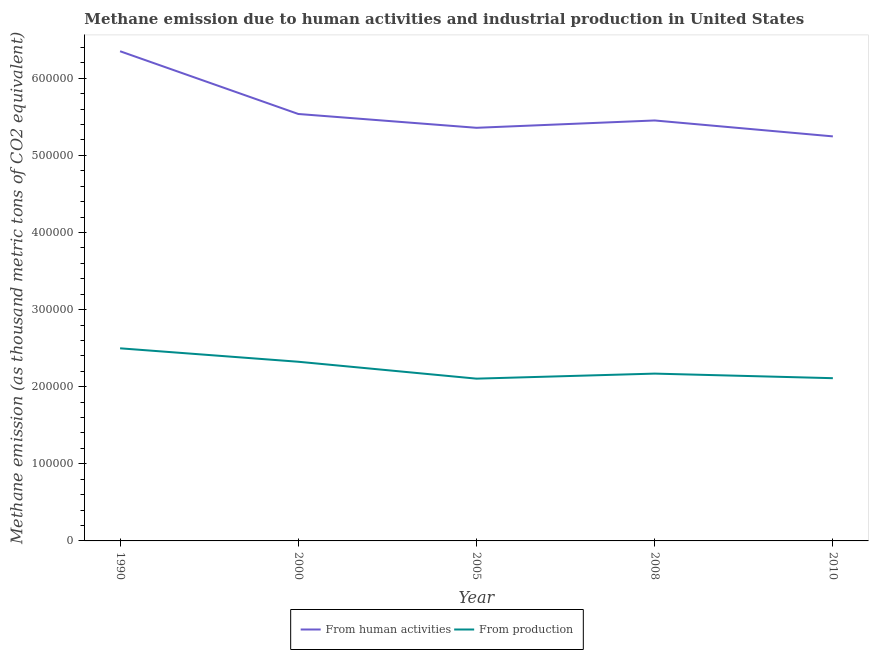How many different coloured lines are there?
Keep it short and to the point. 2. Does the line corresponding to amount of emissions generated from industries intersect with the line corresponding to amount of emissions from human activities?
Make the answer very short. No. What is the amount of emissions from human activities in 2010?
Offer a terse response. 5.25e+05. Across all years, what is the maximum amount of emissions generated from industries?
Your response must be concise. 2.50e+05. Across all years, what is the minimum amount of emissions generated from industries?
Provide a short and direct response. 2.10e+05. In which year was the amount of emissions generated from industries minimum?
Offer a very short reply. 2005. What is the total amount of emissions from human activities in the graph?
Your answer should be compact. 2.79e+06. What is the difference between the amount of emissions generated from industries in 2008 and that in 2010?
Your answer should be very brief. 5939.8. What is the difference between the amount of emissions from human activities in 2010 and the amount of emissions generated from industries in 1990?
Give a very brief answer. 2.75e+05. What is the average amount of emissions generated from industries per year?
Give a very brief answer. 2.24e+05. In the year 2008, what is the difference between the amount of emissions generated from industries and amount of emissions from human activities?
Your answer should be compact. -3.28e+05. What is the ratio of the amount of emissions generated from industries in 1990 to that in 2010?
Provide a short and direct response. 1.18. Is the amount of emissions generated from industries in 2000 less than that in 2010?
Your answer should be very brief. No. Is the difference between the amount of emissions from human activities in 2005 and 2010 greater than the difference between the amount of emissions generated from industries in 2005 and 2010?
Your answer should be very brief. Yes. What is the difference between the highest and the second highest amount of emissions from human activities?
Your answer should be very brief. 8.14e+04. What is the difference between the highest and the lowest amount of emissions generated from industries?
Your answer should be compact. 3.93e+04. In how many years, is the amount of emissions generated from industries greater than the average amount of emissions generated from industries taken over all years?
Keep it short and to the point. 2. Does the amount of emissions generated from industries monotonically increase over the years?
Offer a very short reply. No. Is the amount of emissions generated from industries strictly less than the amount of emissions from human activities over the years?
Make the answer very short. Yes. How many lines are there?
Give a very brief answer. 2. How many years are there in the graph?
Ensure brevity in your answer.  5. What is the difference between two consecutive major ticks on the Y-axis?
Provide a succinct answer. 1.00e+05. Does the graph contain any zero values?
Ensure brevity in your answer.  No. How many legend labels are there?
Your answer should be compact. 2. How are the legend labels stacked?
Ensure brevity in your answer.  Horizontal. What is the title of the graph?
Your answer should be very brief. Methane emission due to human activities and industrial production in United States. What is the label or title of the Y-axis?
Make the answer very short. Methane emission (as thousand metric tons of CO2 equivalent). What is the Methane emission (as thousand metric tons of CO2 equivalent) of From human activities in 1990?
Provide a succinct answer. 6.35e+05. What is the Methane emission (as thousand metric tons of CO2 equivalent) in From production in 1990?
Your answer should be very brief. 2.50e+05. What is the Methane emission (as thousand metric tons of CO2 equivalent) in From human activities in 2000?
Ensure brevity in your answer.  5.54e+05. What is the Methane emission (as thousand metric tons of CO2 equivalent) of From production in 2000?
Offer a terse response. 2.32e+05. What is the Methane emission (as thousand metric tons of CO2 equivalent) in From human activities in 2005?
Offer a very short reply. 5.36e+05. What is the Methane emission (as thousand metric tons of CO2 equivalent) of From production in 2005?
Ensure brevity in your answer.  2.10e+05. What is the Methane emission (as thousand metric tons of CO2 equivalent) in From human activities in 2008?
Provide a short and direct response. 5.45e+05. What is the Methane emission (as thousand metric tons of CO2 equivalent) in From production in 2008?
Ensure brevity in your answer.  2.17e+05. What is the Methane emission (as thousand metric tons of CO2 equivalent) of From human activities in 2010?
Provide a succinct answer. 5.25e+05. What is the Methane emission (as thousand metric tons of CO2 equivalent) in From production in 2010?
Offer a very short reply. 2.11e+05. Across all years, what is the maximum Methane emission (as thousand metric tons of CO2 equivalent) in From human activities?
Offer a very short reply. 6.35e+05. Across all years, what is the maximum Methane emission (as thousand metric tons of CO2 equivalent) in From production?
Provide a succinct answer. 2.50e+05. Across all years, what is the minimum Methane emission (as thousand metric tons of CO2 equivalent) in From human activities?
Your answer should be compact. 5.25e+05. Across all years, what is the minimum Methane emission (as thousand metric tons of CO2 equivalent) of From production?
Offer a terse response. 2.10e+05. What is the total Methane emission (as thousand metric tons of CO2 equivalent) in From human activities in the graph?
Your answer should be compact. 2.79e+06. What is the total Methane emission (as thousand metric tons of CO2 equivalent) in From production in the graph?
Make the answer very short. 1.12e+06. What is the difference between the Methane emission (as thousand metric tons of CO2 equivalent) of From human activities in 1990 and that in 2000?
Offer a terse response. 8.14e+04. What is the difference between the Methane emission (as thousand metric tons of CO2 equivalent) of From production in 1990 and that in 2000?
Your response must be concise. 1.74e+04. What is the difference between the Methane emission (as thousand metric tons of CO2 equivalent) in From human activities in 1990 and that in 2005?
Make the answer very short. 9.93e+04. What is the difference between the Methane emission (as thousand metric tons of CO2 equivalent) in From production in 1990 and that in 2005?
Your response must be concise. 3.93e+04. What is the difference between the Methane emission (as thousand metric tons of CO2 equivalent) in From human activities in 1990 and that in 2008?
Your answer should be very brief. 8.98e+04. What is the difference between the Methane emission (as thousand metric tons of CO2 equivalent) in From production in 1990 and that in 2008?
Provide a short and direct response. 3.28e+04. What is the difference between the Methane emission (as thousand metric tons of CO2 equivalent) of From human activities in 1990 and that in 2010?
Give a very brief answer. 1.10e+05. What is the difference between the Methane emission (as thousand metric tons of CO2 equivalent) in From production in 1990 and that in 2010?
Provide a succinct answer. 3.87e+04. What is the difference between the Methane emission (as thousand metric tons of CO2 equivalent) in From human activities in 2000 and that in 2005?
Your answer should be very brief. 1.79e+04. What is the difference between the Methane emission (as thousand metric tons of CO2 equivalent) of From production in 2000 and that in 2005?
Your response must be concise. 2.19e+04. What is the difference between the Methane emission (as thousand metric tons of CO2 equivalent) in From human activities in 2000 and that in 2008?
Your response must be concise. 8414.7. What is the difference between the Methane emission (as thousand metric tons of CO2 equivalent) in From production in 2000 and that in 2008?
Give a very brief answer. 1.54e+04. What is the difference between the Methane emission (as thousand metric tons of CO2 equivalent) in From human activities in 2000 and that in 2010?
Offer a very short reply. 2.91e+04. What is the difference between the Methane emission (as thousand metric tons of CO2 equivalent) of From production in 2000 and that in 2010?
Offer a terse response. 2.13e+04. What is the difference between the Methane emission (as thousand metric tons of CO2 equivalent) in From human activities in 2005 and that in 2008?
Keep it short and to the point. -9510.3. What is the difference between the Methane emission (as thousand metric tons of CO2 equivalent) of From production in 2005 and that in 2008?
Give a very brief answer. -6538.2. What is the difference between the Methane emission (as thousand metric tons of CO2 equivalent) in From human activities in 2005 and that in 2010?
Make the answer very short. 1.11e+04. What is the difference between the Methane emission (as thousand metric tons of CO2 equivalent) in From production in 2005 and that in 2010?
Your answer should be very brief. -598.4. What is the difference between the Methane emission (as thousand metric tons of CO2 equivalent) in From human activities in 2008 and that in 2010?
Provide a succinct answer. 2.06e+04. What is the difference between the Methane emission (as thousand metric tons of CO2 equivalent) in From production in 2008 and that in 2010?
Ensure brevity in your answer.  5939.8. What is the difference between the Methane emission (as thousand metric tons of CO2 equivalent) in From human activities in 1990 and the Methane emission (as thousand metric tons of CO2 equivalent) in From production in 2000?
Offer a very short reply. 4.03e+05. What is the difference between the Methane emission (as thousand metric tons of CO2 equivalent) of From human activities in 1990 and the Methane emission (as thousand metric tons of CO2 equivalent) of From production in 2005?
Offer a very short reply. 4.25e+05. What is the difference between the Methane emission (as thousand metric tons of CO2 equivalent) of From human activities in 1990 and the Methane emission (as thousand metric tons of CO2 equivalent) of From production in 2008?
Offer a very short reply. 4.18e+05. What is the difference between the Methane emission (as thousand metric tons of CO2 equivalent) of From human activities in 1990 and the Methane emission (as thousand metric tons of CO2 equivalent) of From production in 2010?
Your answer should be compact. 4.24e+05. What is the difference between the Methane emission (as thousand metric tons of CO2 equivalent) of From human activities in 2000 and the Methane emission (as thousand metric tons of CO2 equivalent) of From production in 2005?
Offer a very short reply. 3.43e+05. What is the difference between the Methane emission (as thousand metric tons of CO2 equivalent) of From human activities in 2000 and the Methane emission (as thousand metric tons of CO2 equivalent) of From production in 2008?
Offer a very short reply. 3.37e+05. What is the difference between the Methane emission (as thousand metric tons of CO2 equivalent) of From human activities in 2000 and the Methane emission (as thousand metric tons of CO2 equivalent) of From production in 2010?
Your response must be concise. 3.43e+05. What is the difference between the Methane emission (as thousand metric tons of CO2 equivalent) of From human activities in 2005 and the Methane emission (as thousand metric tons of CO2 equivalent) of From production in 2008?
Your answer should be compact. 3.19e+05. What is the difference between the Methane emission (as thousand metric tons of CO2 equivalent) of From human activities in 2005 and the Methane emission (as thousand metric tons of CO2 equivalent) of From production in 2010?
Your answer should be compact. 3.25e+05. What is the difference between the Methane emission (as thousand metric tons of CO2 equivalent) in From human activities in 2008 and the Methane emission (as thousand metric tons of CO2 equivalent) in From production in 2010?
Provide a succinct answer. 3.34e+05. What is the average Methane emission (as thousand metric tons of CO2 equivalent) of From human activities per year?
Keep it short and to the point. 5.59e+05. What is the average Methane emission (as thousand metric tons of CO2 equivalent) in From production per year?
Ensure brevity in your answer.  2.24e+05. In the year 1990, what is the difference between the Methane emission (as thousand metric tons of CO2 equivalent) of From human activities and Methane emission (as thousand metric tons of CO2 equivalent) of From production?
Your answer should be compact. 3.85e+05. In the year 2000, what is the difference between the Methane emission (as thousand metric tons of CO2 equivalent) of From human activities and Methane emission (as thousand metric tons of CO2 equivalent) of From production?
Provide a short and direct response. 3.21e+05. In the year 2005, what is the difference between the Methane emission (as thousand metric tons of CO2 equivalent) of From human activities and Methane emission (as thousand metric tons of CO2 equivalent) of From production?
Your response must be concise. 3.25e+05. In the year 2008, what is the difference between the Methane emission (as thousand metric tons of CO2 equivalent) in From human activities and Methane emission (as thousand metric tons of CO2 equivalent) in From production?
Offer a terse response. 3.28e+05. In the year 2010, what is the difference between the Methane emission (as thousand metric tons of CO2 equivalent) in From human activities and Methane emission (as thousand metric tons of CO2 equivalent) in From production?
Ensure brevity in your answer.  3.14e+05. What is the ratio of the Methane emission (as thousand metric tons of CO2 equivalent) in From human activities in 1990 to that in 2000?
Your answer should be very brief. 1.15. What is the ratio of the Methane emission (as thousand metric tons of CO2 equivalent) of From production in 1990 to that in 2000?
Your response must be concise. 1.07. What is the ratio of the Methane emission (as thousand metric tons of CO2 equivalent) in From human activities in 1990 to that in 2005?
Offer a terse response. 1.19. What is the ratio of the Methane emission (as thousand metric tons of CO2 equivalent) of From production in 1990 to that in 2005?
Give a very brief answer. 1.19. What is the ratio of the Methane emission (as thousand metric tons of CO2 equivalent) of From human activities in 1990 to that in 2008?
Make the answer very short. 1.16. What is the ratio of the Methane emission (as thousand metric tons of CO2 equivalent) in From production in 1990 to that in 2008?
Keep it short and to the point. 1.15. What is the ratio of the Methane emission (as thousand metric tons of CO2 equivalent) of From human activities in 1990 to that in 2010?
Keep it short and to the point. 1.21. What is the ratio of the Methane emission (as thousand metric tons of CO2 equivalent) in From production in 1990 to that in 2010?
Ensure brevity in your answer.  1.18. What is the ratio of the Methane emission (as thousand metric tons of CO2 equivalent) of From human activities in 2000 to that in 2005?
Offer a terse response. 1.03. What is the ratio of the Methane emission (as thousand metric tons of CO2 equivalent) in From production in 2000 to that in 2005?
Provide a succinct answer. 1.1. What is the ratio of the Methane emission (as thousand metric tons of CO2 equivalent) in From human activities in 2000 to that in 2008?
Your response must be concise. 1.02. What is the ratio of the Methane emission (as thousand metric tons of CO2 equivalent) in From production in 2000 to that in 2008?
Your answer should be very brief. 1.07. What is the ratio of the Methane emission (as thousand metric tons of CO2 equivalent) of From human activities in 2000 to that in 2010?
Provide a succinct answer. 1.06. What is the ratio of the Methane emission (as thousand metric tons of CO2 equivalent) of From production in 2000 to that in 2010?
Offer a terse response. 1.1. What is the ratio of the Methane emission (as thousand metric tons of CO2 equivalent) of From human activities in 2005 to that in 2008?
Provide a short and direct response. 0.98. What is the ratio of the Methane emission (as thousand metric tons of CO2 equivalent) of From production in 2005 to that in 2008?
Your response must be concise. 0.97. What is the ratio of the Methane emission (as thousand metric tons of CO2 equivalent) of From human activities in 2005 to that in 2010?
Offer a terse response. 1.02. What is the ratio of the Methane emission (as thousand metric tons of CO2 equivalent) in From human activities in 2008 to that in 2010?
Offer a very short reply. 1.04. What is the ratio of the Methane emission (as thousand metric tons of CO2 equivalent) of From production in 2008 to that in 2010?
Your response must be concise. 1.03. What is the difference between the highest and the second highest Methane emission (as thousand metric tons of CO2 equivalent) in From human activities?
Offer a terse response. 8.14e+04. What is the difference between the highest and the second highest Methane emission (as thousand metric tons of CO2 equivalent) in From production?
Give a very brief answer. 1.74e+04. What is the difference between the highest and the lowest Methane emission (as thousand metric tons of CO2 equivalent) of From human activities?
Provide a succinct answer. 1.10e+05. What is the difference between the highest and the lowest Methane emission (as thousand metric tons of CO2 equivalent) in From production?
Offer a terse response. 3.93e+04. 